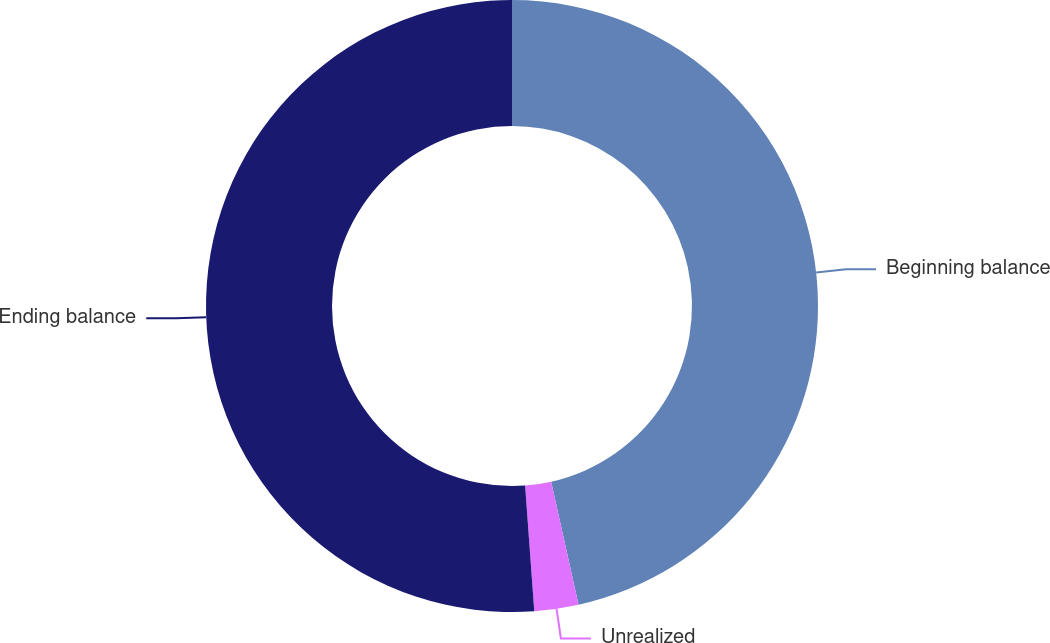Convert chart to OTSL. <chart><loc_0><loc_0><loc_500><loc_500><pie_chart><fcel>Beginning balance<fcel>Unrealized<fcel>Ending balance<nl><fcel>46.51%<fcel>2.33%<fcel>51.16%<nl></chart> 